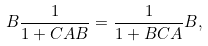<formula> <loc_0><loc_0><loc_500><loc_500>B \frac { 1 } { 1 + C A B } = \frac { 1 } { 1 + B C A } B ,</formula> 